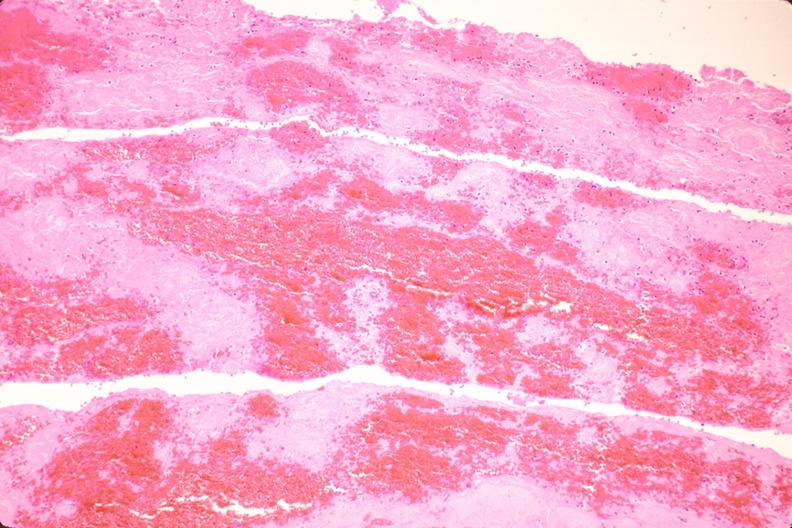what does this image show?
Answer the question using a single word or phrase. Thromboembolus from leg veins in pulmonary artery 